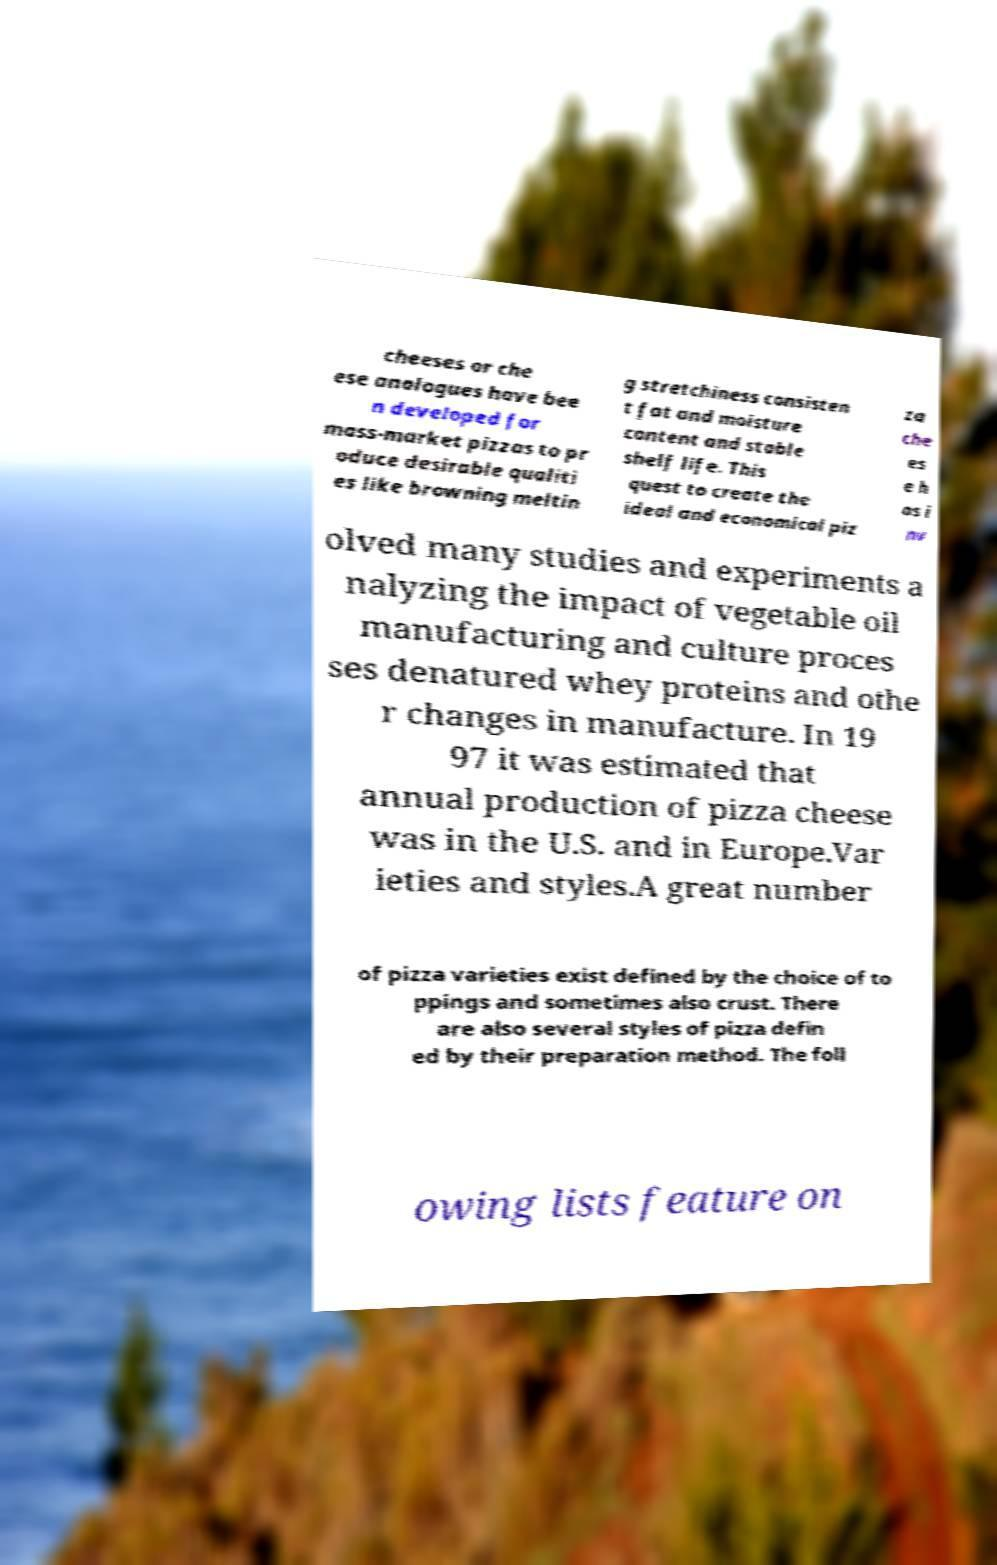Could you assist in decoding the text presented in this image and type it out clearly? cheeses or che ese analogues have bee n developed for mass-market pizzas to pr oduce desirable qualiti es like browning meltin g stretchiness consisten t fat and moisture content and stable shelf life. This quest to create the ideal and economical piz za che es e h as i nv olved many studies and experiments a nalyzing the impact of vegetable oil manufacturing and culture proces ses denatured whey proteins and othe r changes in manufacture. In 19 97 it was estimated that annual production of pizza cheese was in the U.S. and in Europe.Var ieties and styles.A great number of pizza varieties exist defined by the choice of to ppings and sometimes also crust. There are also several styles of pizza defin ed by their preparation method. The foll owing lists feature on 